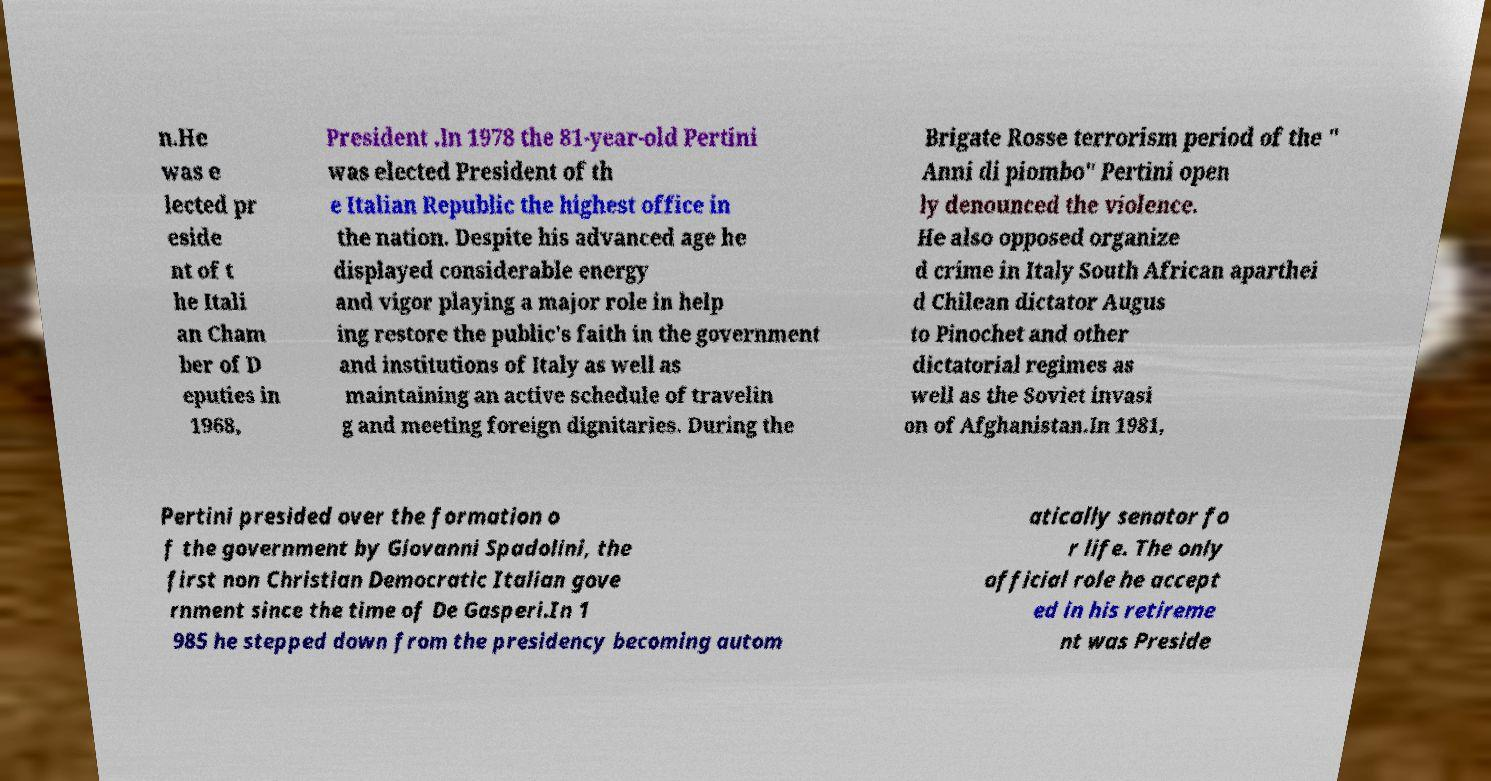Please read and relay the text visible in this image. What does it say? n.He was e lected pr eside nt of t he Itali an Cham ber of D eputies in 1968, President .In 1978 the 81-year-old Pertini was elected President of th e Italian Republic the highest office in the nation. Despite his advanced age he displayed considerable energy and vigor playing a major role in help ing restore the public's faith in the government and institutions of Italy as well as maintaining an active schedule of travelin g and meeting foreign dignitaries. During the Brigate Rosse terrorism period of the " Anni di piombo" Pertini open ly denounced the violence. He also opposed organize d crime in Italy South African aparthei d Chilean dictator Augus to Pinochet and other dictatorial regimes as well as the Soviet invasi on of Afghanistan.In 1981, Pertini presided over the formation o f the government by Giovanni Spadolini, the first non Christian Democratic Italian gove rnment since the time of De Gasperi.In 1 985 he stepped down from the presidency becoming autom atically senator fo r life. The only official role he accept ed in his retireme nt was Preside 